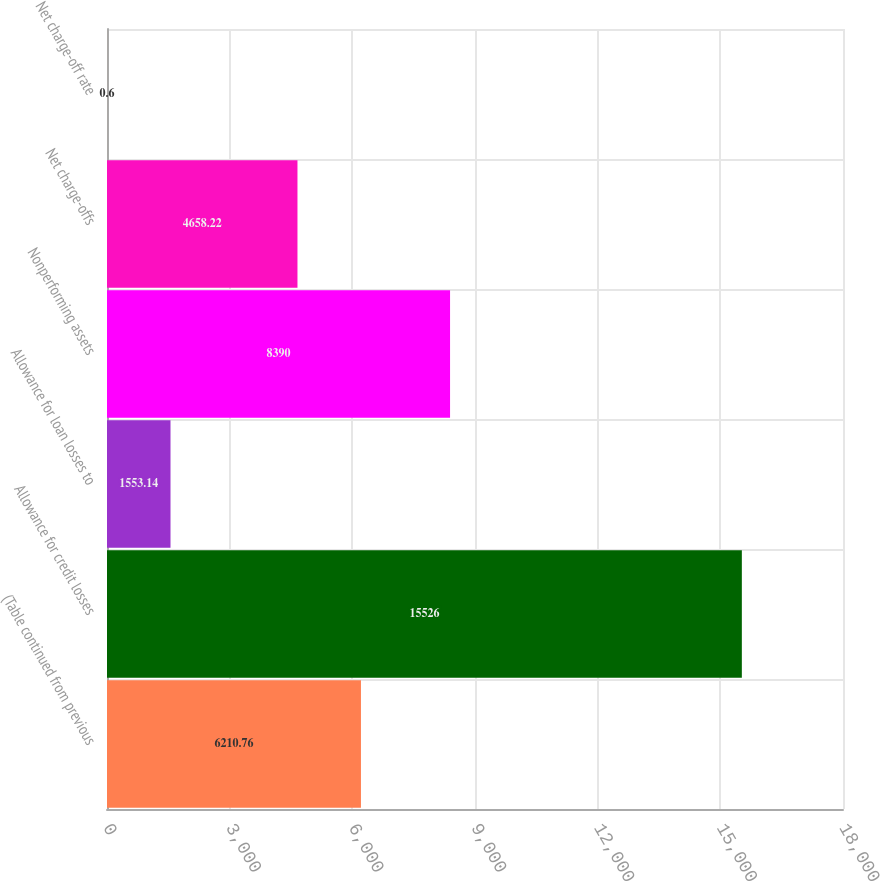<chart> <loc_0><loc_0><loc_500><loc_500><bar_chart><fcel>(Table continued from previous<fcel>Allowance for credit losses<fcel>Allowance for loan losses to<fcel>Nonperforming assets<fcel>Net charge-offs<fcel>Net charge-off rate<nl><fcel>6210.76<fcel>15526<fcel>1553.14<fcel>8390<fcel>4658.22<fcel>0.6<nl></chart> 